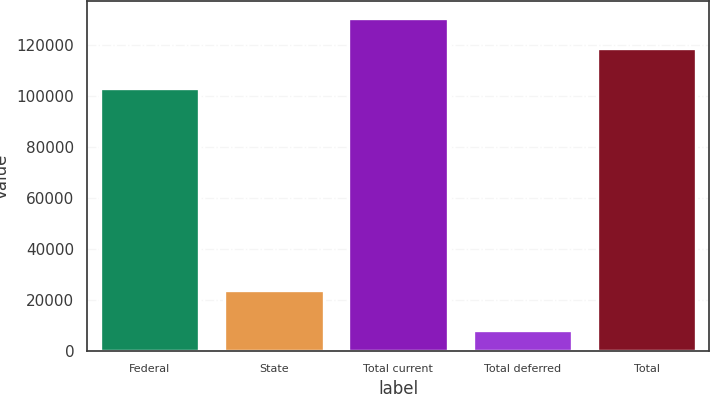Convert chart. <chart><loc_0><loc_0><loc_500><loc_500><bar_chart><fcel>Federal<fcel>State<fcel>Total current<fcel>Total deferred<fcel>Total<nl><fcel>103344<fcel>23939<fcel>130901<fcel>8282<fcel>119001<nl></chart> 